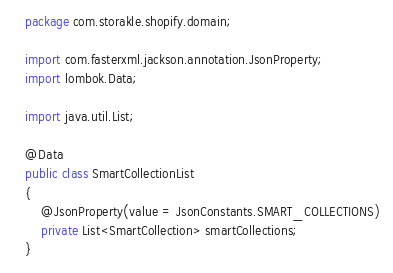Convert code to text. <code><loc_0><loc_0><loc_500><loc_500><_Java_>package com.storakle.shopify.domain;

import com.fasterxml.jackson.annotation.JsonProperty;
import lombok.Data;

import java.util.List;

@Data
public class SmartCollectionList
{
    @JsonProperty(value = JsonConstants.SMART_COLLECTIONS)
    private List<SmartCollection> smartCollections;
}
</code> 